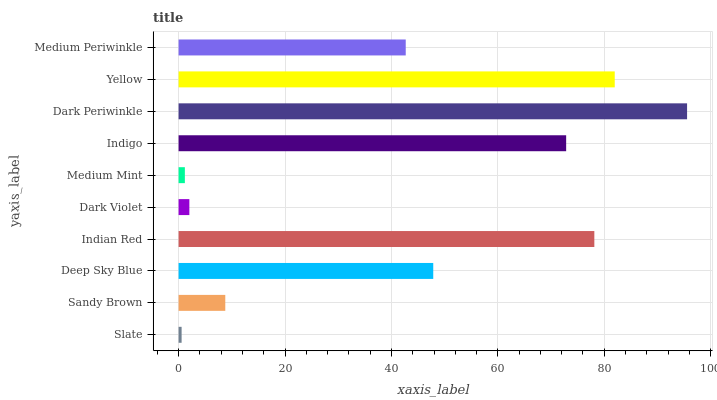Is Slate the minimum?
Answer yes or no. Yes. Is Dark Periwinkle the maximum?
Answer yes or no. Yes. Is Sandy Brown the minimum?
Answer yes or no. No. Is Sandy Brown the maximum?
Answer yes or no. No. Is Sandy Brown greater than Slate?
Answer yes or no. Yes. Is Slate less than Sandy Brown?
Answer yes or no. Yes. Is Slate greater than Sandy Brown?
Answer yes or no. No. Is Sandy Brown less than Slate?
Answer yes or no. No. Is Deep Sky Blue the high median?
Answer yes or no. Yes. Is Medium Periwinkle the low median?
Answer yes or no. Yes. Is Slate the high median?
Answer yes or no. No. Is Dark Violet the low median?
Answer yes or no. No. 